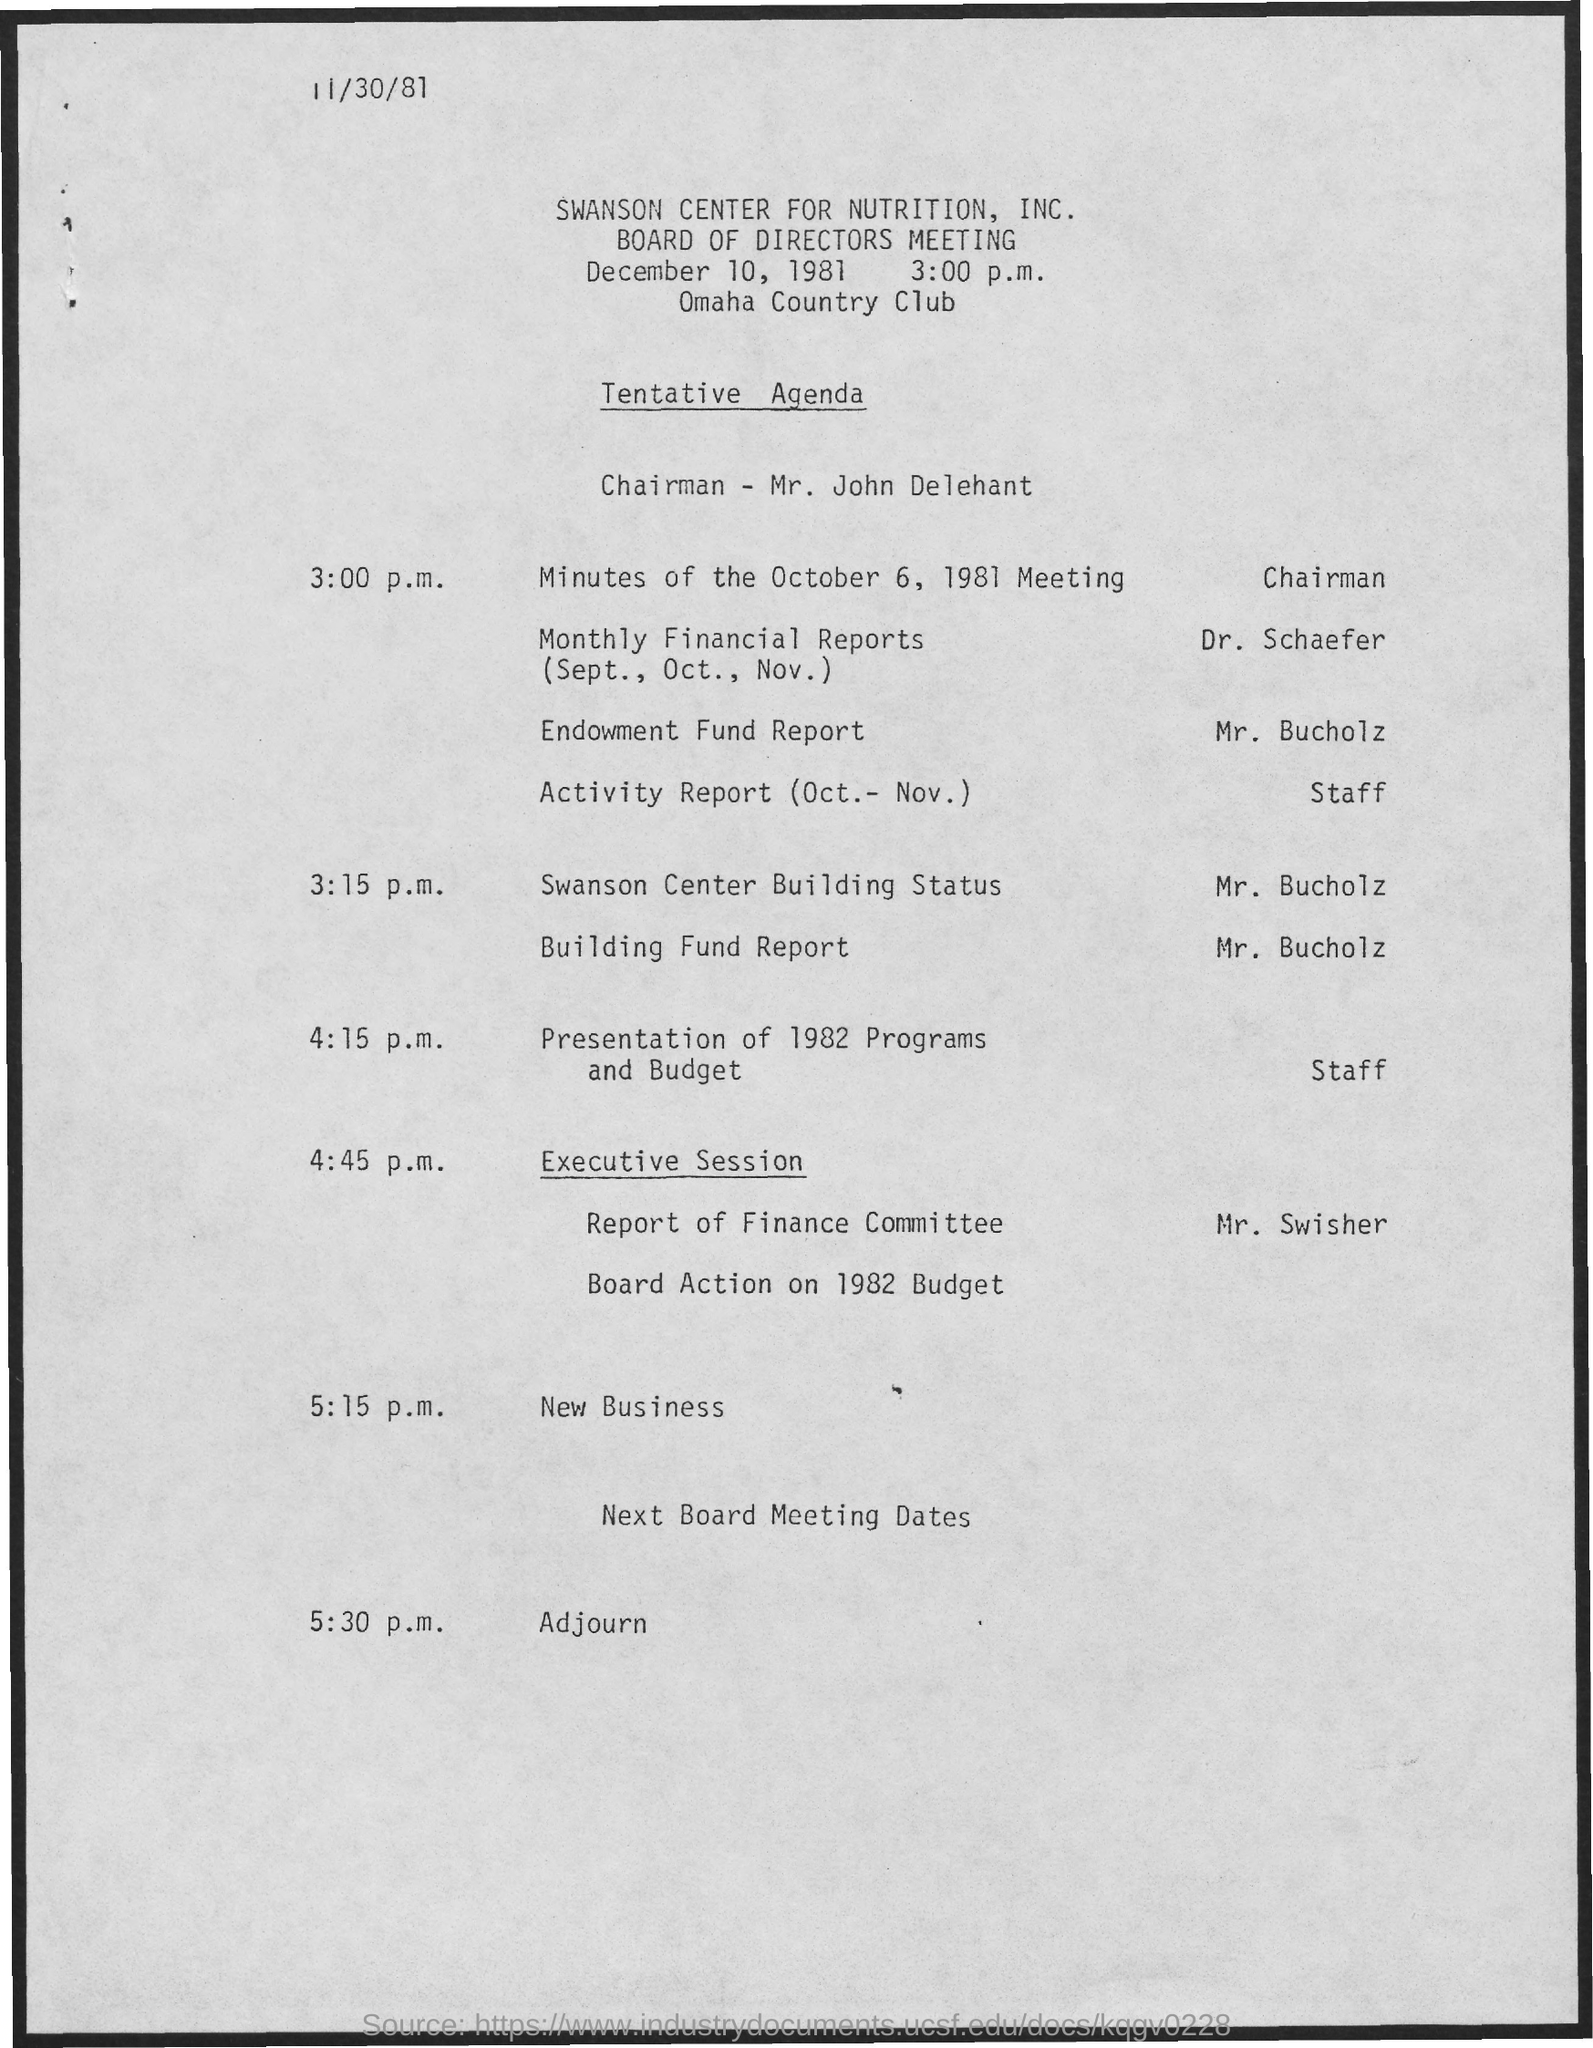Point out several critical features in this image. The Board of Directors meeting is held at the Omaha Country Club. At 3:15 p.m., Mr. Bucholz will present the Building Fund Report as per the agenda. The minutes of the October 6, 1981 meeting are to be presented at 3:00 p.m. by the chairman. Dr. Schaefer presented the monthly financial reports for September, October, and November in the meeting. The Report of the Finance Committee will be presented by Mr. Swisher in the meeting. 